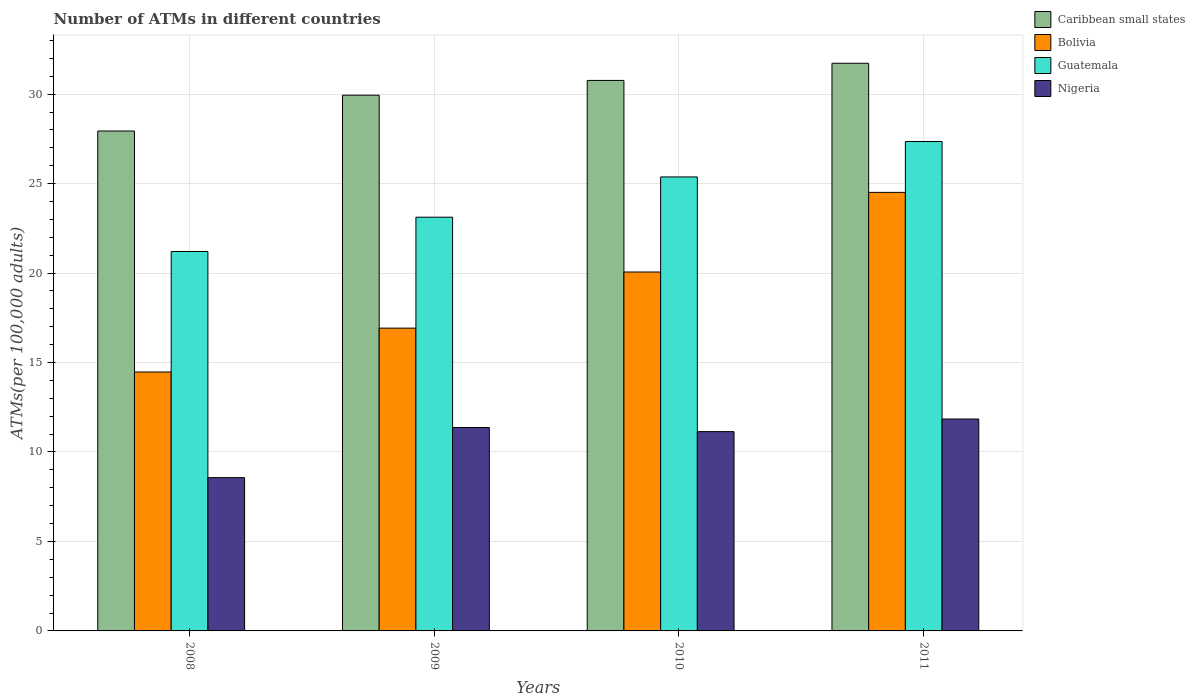Are the number of bars per tick equal to the number of legend labels?
Make the answer very short. Yes. Are the number of bars on each tick of the X-axis equal?
Offer a very short reply. Yes. How many bars are there on the 1st tick from the left?
Provide a short and direct response. 4. What is the label of the 3rd group of bars from the left?
Provide a succinct answer. 2010. What is the number of ATMs in Nigeria in 2008?
Offer a terse response. 8.57. Across all years, what is the maximum number of ATMs in Guatemala?
Offer a terse response. 27.35. Across all years, what is the minimum number of ATMs in Guatemala?
Provide a succinct answer. 21.21. In which year was the number of ATMs in Nigeria maximum?
Your answer should be compact. 2011. What is the total number of ATMs in Caribbean small states in the graph?
Provide a short and direct response. 120.38. What is the difference between the number of ATMs in Bolivia in 2009 and that in 2010?
Provide a short and direct response. -3.14. What is the difference between the number of ATMs in Guatemala in 2011 and the number of ATMs in Caribbean small states in 2008?
Your response must be concise. -0.59. What is the average number of ATMs in Guatemala per year?
Your answer should be very brief. 24.26. In the year 2011, what is the difference between the number of ATMs in Bolivia and number of ATMs in Caribbean small states?
Keep it short and to the point. -7.22. In how many years, is the number of ATMs in Caribbean small states greater than 30?
Give a very brief answer. 2. What is the ratio of the number of ATMs in Bolivia in 2008 to that in 2009?
Your answer should be very brief. 0.86. Is the difference between the number of ATMs in Bolivia in 2010 and 2011 greater than the difference between the number of ATMs in Caribbean small states in 2010 and 2011?
Offer a terse response. No. What is the difference between the highest and the second highest number of ATMs in Nigeria?
Ensure brevity in your answer.  0.47. What is the difference between the highest and the lowest number of ATMs in Bolivia?
Offer a terse response. 10.04. Is the sum of the number of ATMs in Nigeria in 2008 and 2009 greater than the maximum number of ATMs in Caribbean small states across all years?
Make the answer very short. No. What does the 1st bar from the left in 2009 represents?
Offer a very short reply. Caribbean small states. What does the 4th bar from the right in 2008 represents?
Give a very brief answer. Caribbean small states. Is it the case that in every year, the sum of the number of ATMs in Bolivia and number of ATMs in Nigeria is greater than the number of ATMs in Caribbean small states?
Offer a very short reply. No. How many bars are there?
Your answer should be very brief. 16. What is the difference between two consecutive major ticks on the Y-axis?
Offer a terse response. 5. Are the values on the major ticks of Y-axis written in scientific E-notation?
Your response must be concise. No. Does the graph contain any zero values?
Your response must be concise. No. Does the graph contain grids?
Your answer should be compact. Yes. What is the title of the graph?
Keep it short and to the point. Number of ATMs in different countries. Does "Gabon" appear as one of the legend labels in the graph?
Keep it short and to the point. No. What is the label or title of the Y-axis?
Your response must be concise. ATMs(per 100,0 adults). What is the ATMs(per 100,000 adults) of Caribbean small states in 2008?
Give a very brief answer. 27.94. What is the ATMs(per 100,000 adults) of Bolivia in 2008?
Keep it short and to the point. 14.47. What is the ATMs(per 100,000 adults) of Guatemala in 2008?
Your answer should be compact. 21.21. What is the ATMs(per 100,000 adults) in Nigeria in 2008?
Your response must be concise. 8.57. What is the ATMs(per 100,000 adults) of Caribbean small states in 2009?
Offer a terse response. 29.94. What is the ATMs(per 100,000 adults) of Bolivia in 2009?
Give a very brief answer. 16.92. What is the ATMs(per 100,000 adults) in Guatemala in 2009?
Provide a short and direct response. 23.12. What is the ATMs(per 100,000 adults) of Nigeria in 2009?
Keep it short and to the point. 11.37. What is the ATMs(per 100,000 adults) in Caribbean small states in 2010?
Your answer should be compact. 30.77. What is the ATMs(per 100,000 adults) in Bolivia in 2010?
Make the answer very short. 20.06. What is the ATMs(per 100,000 adults) of Guatemala in 2010?
Your answer should be compact. 25.37. What is the ATMs(per 100,000 adults) of Nigeria in 2010?
Make the answer very short. 11.14. What is the ATMs(per 100,000 adults) in Caribbean small states in 2011?
Offer a terse response. 31.73. What is the ATMs(per 100,000 adults) in Bolivia in 2011?
Keep it short and to the point. 24.51. What is the ATMs(per 100,000 adults) in Guatemala in 2011?
Your answer should be very brief. 27.35. What is the ATMs(per 100,000 adults) of Nigeria in 2011?
Offer a terse response. 11.84. Across all years, what is the maximum ATMs(per 100,000 adults) of Caribbean small states?
Give a very brief answer. 31.73. Across all years, what is the maximum ATMs(per 100,000 adults) of Bolivia?
Your answer should be very brief. 24.51. Across all years, what is the maximum ATMs(per 100,000 adults) of Guatemala?
Give a very brief answer. 27.35. Across all years, what is the maximum ATMs(per 100,000 adults) in Nigeria?
Provide a short and direct response. 11.84. Across all years, what is the minimum ATMs(per 100,000 adults) of Caribbean small states?
Provide a succinct answer. 27.94. Across all years, what is the minimum ATMs(per 100,000 adults) in Bolivia?
Make the answer very short. 14.47. Across all years, what is the minimum ATMs(per 100,000 adults) of Guatemala?
Your answer should be compact. 21.21. Across all years, what is the minimum ATMs(per 100,000 adults) of Nigeria?
Provide a short and direct response. 8.57. What is the total ATMs(per 100,000 adults) of Caribbean small states in the graph?
Offer a terse response. 120.38. What is the total ATMs(per 100,000 adults) of Bolivia in the graph?
Keep it short and to the point. 75.96. What is the total ATMs(per 100,000 adults) in Guatemala in the graph?
Offer a terse response. 97.06. What is the total ATMs(per 100,000 adults) of Nigeria in the graph?
Ensure brevity in your answer.  42.92. What is the difference between the ATMs(per 100,000 adults) in Caribbean small states in 2008 and that in 2009?
Give a very brief answer. -2. What is the difference between the ATMs(per 100,000 adults) of Bolivia in 2008 and that in 2009?
Your response must be concise. -2.45. What is the difference between the ATMs(per 100,000 adults) in Guatemala in 2008 and that in 2009?
Offer a terse response. -1.92. What is the difference between the ATMs(per 100,000 adults) of Nigeria in 2008 and that in 2009?
Provide a succinct answer. -2.8. What is the difference between the ATMs(per 100,000 adults) in Caribbean small states in 2008 and that in 2010?
Provide a short and direct response. -2.83. What is the difference between the ATMs(per 100,000 adults) in Bolivia in 2008 and that in 2010?
Offer a very short reply. -5.59. What is the difference between the ATMs(per 100,000 adults) in Guatemala in 2008 and that in 2010?
Make the answer very short. -4.17. What is the difference between the ATMs(per 100,000 adults) of Nigeria in 2008 and that in 2010?
Your answer should be very brief. -2.57. What is the difference between the ATMs(per 100,000 adults) of Caribbean small states in 2008 and that in 2011?
Ensure brevity in your answer.  -3.79. What is the difference between the ATMs(per 100,000 adults) of Bolivia in 2008 and that in 2011?
Ensure brevity in your answer.  -10.04. What is the difference between the ATMs(per 100,000 adults) of Guatemala in 2008 and that in 2011?
Your answer should be compact. -6.15. What is the difference between the ATMs(per 100,000 adults) in Nigeria in 2008 and that in 2011?
Offer a terse response. -3.28. What is the difference between the ATMs(per 100,000 adults) of Caribbean small states in 2009 and that in 2010?
Make the answer very short. -0.82. What is the difference between the ATMs(per 100,000 adults) of Bolivia in 2009 and that in 2010?
Provide a succinct answer. -3.14. What is the difference between the ATMs(per 100,000 adults) in Guatemala in 2009 and that in 2010?
Offer a very short reply. -2.25. What is the difference between the ATMs(per 100,000 adults) of Nigeria in 2009 and that in 2010?
Offer a terse response. 0.23. What is the difference between the ATMs(per 100,000 adults) in Caribbean small states in 2009 and that in 2011?
Offer a terse response. -1.78. What is the difference between the ATMs(per 100,000 adults) of Bolivia in 2009 and that in 2011?
Offer a terse response. -7.59. What is the difference between the ATMs(per 100,000 adults) in Guatemala in 2009 and that in 2011?
Your answer should be very brief. -4.23. What is the difference between the ATMs(per 100,000 adults) of Nigeria in 2009 and that in 2011?
Your response must be concise. -0.47. What is the difference between the ATMs(per 100,000 adults) in Caribbean small states in 2010 and that in 2011?
Provide a short and direct response. -0.96. What is the difference between the ATMs(per 100,000 adults) in Bolivia in 2010 and that in 2011?
Provide a short and direct response. -4.45. What is the difference between the ATMs(per 100,000 adults) in Guatemala in 2010 and that in 2011?
Your response must be concise. -1.98. What is the difference between the ATMs(per 100,000 adults) in Nigeria in 2010 and that in 2011?
Your response must be concise. -0.7. What is the difference between the ATMs(per 100,000 adults) in Caribbean small states in 2008 and the ATMs(per 100,000 adults) in Bolivia in 2009?
Offer a terse response. 11.02. What is the difference between the ATMs(per 100,000 adults) of Caribbean small states in 2008 and the ATMs(per 100,000 adults) of Guatemala in 2009?
Your response must be concise. 4.82. What is the difference between the ATMs(per 100,000 adults) of Caribbean small states in 2008 and the ATMs(per 100,000 adults) of Nigeria in 2009?
Offer a terse response. 16.57. What is the difference between the ATMs(per 100,000 adults) of Bolivia in 2008 and the ATMs(per 100,000 adults) of Guatemala in 2009?
Offer a terse response. -8.65. What is the difference between the ATMs(per 100,000 adults) of Bolivia in 2008 and the ATMs(per 100,000 adults) of Nigeria in 2009?
Make the answer very short. 3.1. What is the difference between the ATMs(per 100,000 adults) in Guatemala in 2008 and the ATMs(per 100,000 adults) in Nigeria in 2009?
Keep it short and to the point. 9.84. What is the difference between the ATMs(per 100,000 adults) in Caribbean small states in 2008 and the ATMs(per 100,000 adults) in Bolivia in 2010?
Your response must be concise. 7.88. What is the difference between the ATMs(per 100,000 adults) in Caribbean small states in 2008 and the ATMs(per 100,000 adults) in Guatemala in 2010?
Your answer should be compact. 2.57. What is the difference between the ATMs(per 100,000 adults) in Caribbean small states in 2008 and the ATMs(per 100,000 adults) in Nigeria in 2010?
Provide a succinct answer. 16.8. What is the difference between the ATMs(per 100,000 adults) in Bolivia in 2008 and the ATMs(per 100,000 adults) in Guatemala in 2010?
Keep it short and to the point. -10.9. What is the difference between the ATMs(per 100,000 adults) in Bolivia in 2008 and the ATMs(per 100,000 adults) in Nigeria in 2010?
Give a very brief answer. 3.33. What is the difference between the ATMs(per 100,000 adults) in Guatemala in 2008 and the ATMs(per 100,000 adults) in Nigeria in 2010?
Make the answer very short. 10.07. What is the difference between the ATMs(per 100,000 adults) in Caribbean small states in 2008 and the ATMs(per 100,000 adults) in Bolivia in 2011?
Your response must be concise. 3.43. What is the difference between the ATMs(per 100,000 adults) in Caribbean small states in 2008 and the ATMs(per 100,000 adults) in Guatemala in 2011?
Give a very brief answer. 0.59. What is the difference between the ATMs(per 100,000 adults) in Caribbean small states in 2008 and the ATMs(per 100,000 adults) in Nigeria in 2011?
Provide a short and direct response. 16.1. What is the difference between the ATMs(per 100,000 adults) in Bolivia in 2008 and the ATMs(per 100,000 adults) in Guatemala in 2011?
Your response must be concise. -12.88. What is the difference between the ATMs(per 100,000 adults) of Bolivia in 2008 and the ATMs(per 100,000 adults) of Nigeria in 2011?
Make the answer very short. 2.63. What is the difference between the ATMs(per 100,000 adults) of Guatemala in 2008 and the ATMs(per 100,000 adults) of Nigeria in 2011?
Provide a succinct answer. 9.36. What is the difference between the ATMs(per 100,000 adults) of Caribbean small states in 2009 and the ATMs(per 100,000 adults) of Bolivia in 2010?
Keep it short and to the point. 9.88. What is the difference between the ATMs(per 100,000 adults) in Caribbean small states in 2009 and the ATMs(per 100,000 adults) in Guatemala in 2010?
Your response must be concise. 4.57. What is the difference between the ATMs(per 100,000 adults) of Caribbean small states in 2009 and the ATMs(per 100,000 adults) of Nigeria in 2010?
Give a very brief answer. 18.8. What is the difference between the ATMs(per 100,000 adults) of Bolivia in 2009 and the ATMs(per 100,000 adults) of Guatemala in 2010?
Offer a terse response. -8.45. What is the difference between the ATMs(per 100,000 adults) of Bolivia in 2009 and the ATMs(per 100,000 adults) of Nigeria in 2010?
Your response must be concise. 5.78. What is the difference between the ATMs(per 100,000 adults) in Guatemala in 2009 and the ATMs(per 100,000 adults) in Nigeria in 2010?
Ensure brevity in your answer.  11.98. What is the difference between the ATMs(per 100,000 adults) in Caribbean small states in 2009 and the ATMs(per 100,000 adults) in Bolivia in 2011?
Give a very brief answer. 5.43. What is the difference between the ATMs(per 100,000 adults) of Caribbean small states in 2009 and the ATMs(per 100,000 adults) of Guatemala in 2011?
Provide a succinct answer. 2.59. What is the difference between the ATMs(per 100,000 adults) of Caribbean small states in 2009 and the ATMs(per 100,000 adults) of Nigeria in 2011?
Your answer should be compact. 18.1. What is the difference between the ATMs(per 100,000 adults) in Bolivia in 2009 and the ATMs(per 100,000 adults) in Guatemala in 2011?
Keep it short and to the point. -10.43. What is the difference between the ATMs(per 100,000 adults) in Bolivia in 2009 and the ATMs(per 100,000 adults) in Nigeria in 2011?
Offer a very short reply. 5.08. What is the difference between the ATMs(per 100,000 adults) in Guatemala in 2009 and the ATMs(per 100,000 adults) in Nigeria in 2011?
Your answer should be compact. 11.28. What is the difference between the ATMs(per 100,000 adults) of Caribbean small states in 2010 and the ATMs(per 100,000 adults) of Bolivia in 2011?
Give a very brief answer. 6.26. What is the difference between the ATMs(per 100,000 adults) in Caribbean small states in 2010 and the ATMs(per 100,000 adults) in Guatemala in 2011?
Make the answer very short. 3.41. What is the difference between the ATMs(per 100,000 adults) of Caribbean small states in 2010 and the ATMs(per 100,000 adults) of Nigeria in 2011?
Offer a very short reply. 18.92. What is the difference between the ATMs(per 100,000 adults) in Bolivia in 2010 and the ATMs(per 100,000 adults) in Guatemala in 2011?
Your answer should be very brief. -7.29. What is the difference between the ATMs(per 100,000 adults) of Bolivia in 2010 and the ATMs(per 100,000 adults) of Nigeria in 2011?
Offer a terse response. 8.22. What is the difference between the ATMs(per 100,000 adults) of Guatemala in 2010 and the ATMs(per 100,000 adults) of Nigeria in 2011?
Provide a short and direct response. 13.53. What is the average ATMs(per 100,000 adults) in Caribbean small states per year?
Give a very brief answer. 30.09. What is the average ATMs(per 100,000 adults) of Bolivia per year?
Offer a very short reply. 18.99. What is the average ATMs(per 100,000 adults) of Guatemala per year?
Keep it short and to the point. 24.26. What is the average ATMs(per 100,000 adults) in Nigeria per year?
Provide a succinct answer. 10.73. In the year 2008, what is the difference between the ATMs(per 100,000 adults) in Caribbean small states and ATMs(per 100,000 adults) in Bolivia?
Give a very brief answer. 13.47. In the year 2008, what is the difference between the ATMs(per 100,000 adults) of Caribbean small states and ATMs(per 100,000 adults) of Guatemala?
Your answer should be very brief. 6.73. In the year 2008, what is the difference between the ATMs(per 100,000 adults) of Caribbean small states and ATMs(per 100,000 adults) of Nigeria?
Keep it short and to the point. 19.37. In the year 2008, what is the difference between the ATMs(per 100,000 adults) of Bolivia and ATMs(per 100,000 adults) of Guatemala?
Your response must be concise. -6.74. In the year 2008, what is the difference between the ATMs(per 100,000 adults) of Bolivia and ATMs(per 100,000 adults) of Nigeria?
Your answer should be compact. 5.9. In the year 2008, what is the difference between the ATMs(per 100,000 adults) of Guatemala and ATMs(per 100,000 adults) of Nigeria?
Make the answer very short. 12.64. In the year 2009, what is the difference between the ATMs(per 100,000 adults) in Caribbean small states and ATMs(per 100,000 adults) in Bolivia?
Your answer should be very brief. 13.02. In the year 2009, what is the difference between the ATMs(per 100,000 adults) of Caribbean small states and ATMs(per 100,000 adults) of Guatemala?
Provide a succinct answer. 6.82. In the year 2009, what is the difference between the ATMs(per 100,000 adults) of Caribbean small states and ATMs(per 100,000 adults) of Nigeria?
Offer a terse response. 18.57. In the year 2009, what is the difference between the ATMs(per 100,000 adults) in Bolivia and ATMs(per 100,000 adults) in Guatemala?
Ensure brevity in your answer.  -6.2. In the year 2009, what is the difference between the ATMs(per 100,000 adults) in Bolivia and ATMs(per 100,000 adults) in Nigeria?
Provide a succinct answer. 5.55. In the year 2009, what is the difference between the ATMs(per 100,000 adults) of Guatemala and ATMs(per 100,000 adults) of Nigeria?
Your answer should be very brief. 11.75. In the year 2010, what is the difference between the ATMs(per 100,000 adults) in Caribbean small states and ATMs(per 100,000 adults) in Bolivia?
Your answer should be very brief. 10.71. In the year 2010, what is the difference between the ATMs(per 100,000 adults) of Caribbean small states and ATMs(per 100,000 adults) of Guatemala?
Your answer should be compact. 5.39. In the year 2010, what is the difference between the ATMs(per 100,000 adults) in Caribbean small states and ATMs(per 100,000 adults) in Nigeria?
Offer a terse response. 19.63. In the year 2010, what is the difference between the ATMs(per 100,000 adults) of Bolivia and ATMs(per 100,000 adults) of Guatemala?
Give a very brief answer. -5.31. In the year 2010, what is the difference between the ATMs(per 100,000 adults) in Bolivia and ATMs(per 100,000 adults) in Nigeria?
Offer a very short reply. 8.92. In the year 2010, what is the difference between the ATMs(per 100,000 adults) in Guatemala and ATMs(per 100,000 adults) in Nigeria?
Provide a short and direct response. 14.23. In the year 2011, what is the difference between the ATMs(per 100,000 adults) in Caribbean small states and ATMs(per 100,000 adults) in Bolivia?
Your answer should be compact. 7.22. In the year 2011, what is the difference between the ATMs(per 100,000 adults) in Caribbean small states and ATMs(per 100,000 adults) in Guatemala?
Keep it short and to the point. 4.37. In the year 2011, what is the difference between the ATMs(per 100,000 adults) of Caribbean small states and ATMs(per 100,000 adults) of Nigeria?
Keep it short and to the point. 19.88. In the year 2011, what is the difference between the ATMs(per 100,000 adults) in Bolivia and ATMs(per 100,000 adults) in Guatemala?
Provide a succinct answer. -2.84. In the year 2011, what is the difference between the ATMs(per 100,000 adults) of Bolivia and ATMs(per 100,000 adults) of Nigeria?
Your response must be concise. 12.67. In the year 2011, what is the difference between the ATMs(per 100,000 adults) in Guatemala and ATMs(per 100,000 adults) in Nigeria?
Your answer should be very brief. 15.51. What is the ratio of the ATMs(per 100,000 adults) in Caribbean small states in 2008 to that in 2009?
Your answer should be compact. 0.93. What is the ratio of the ATMs(per 100,000 adults) of Bolivia in 2008 to that in 2009?
Make the answer very short. 0.86. What is the ratio of the ATMs(per 100,000 adults) in Guatemala in 2008 to that in 2009?
Provide a succinct answer. 0.92. What is the ratio of the ATMs(per 100,000 adults) of Nigeria in 2008 to that in 2009?
Make the answer very short. 0.75. What is the ratio of the ATMs(per 100,000 adults) in Caribbean small states in 2008 to that in 2010?
Keep it short and to the point. 0.91. What is the ratio of the ATMs(per 100,000 adults) in Bolivia in 2008 to that in 2010?
Offer a very short reply. 0.72. What is the ratio of the ATMs(per 100,000 adults) of Guatemala in 2008 to that in 2010?
Your response must be concise. 0.84. What is the ratio of the ATMs(per 100,000 adults) in Nigeria in 2008 to that in 2010?
Offer a very short reply. 0.77. What is the ratio of the ATMs(per 100,000 adults) of Caribbean small states in 2008 to that in 2011?
Ensure brevity in your answer.  0.88. What is the ratio of the ATMs(per 100,000 adults) of Bolivia in 2008 to that in 2011?
Provide a short and direct response. 0.59. What is the ratio of the ATMs(per 100,000 adults) of Guatemala in 2008 to that in 2011?
Your response must be concise. 0.78. What is the ratio of the ATMs(per 100,000 adults) in Nigeria in 2008 to that in 2011?
Provide a short and direct response. 0.72. What is the ratio of the ATMs(per 100,000 adults) of Caribbean small states in 2009 to that in 2010?
Your response must be concise. 0.97. What is the ratio of the ATMs(per 100,000 adults) of Bolivia in 2009 to that in 2010?
Offer a very short reply. 0.84. What is the ratio of the ATMs(per 100,000 adults) in Guatemala in 2009 to that in 2010?
Make the answer very short. 0.91. What is the ratio of the ATMs(per 100,000 adults) in Nigeria in 2009 to that in 2010?
Provide a short and direct response. 1.02. What is the ratio of the ATMs(per 100,000 adults) of Caribbean small states in 2009 to that in 2011?
Ensure brevity in your answer.  0.94. What is the ratio of the ATMs(per 100,000 adults) of Bolivia in 2009 to that in 2011?
Offer a terse response. 0.69. What is the ratio of the ATMs(per 100,000 adults) in Guatemala in 2009 to that in 2011?
Ensure brevity in your answer.  0.85. What is the ratio of the ATMs(per 100,000 adults) in Nigeria in 2009 to that in 2011?
Provide a succinct answer. 0.96. What is the ratio of the ATMs(per 100,000 adults) in Caribbean small states in 2010 to that in 2011?
Your answer should be very brief. 0.97. What is the ratio of the ATMs(per 100,000 adults) of Bolivia in 2010 to that in 2011?
Offer a terse response. 0.82. What is the ratio of the ATMs(per 100,000 adults) of Guatemala in 2010 to that in 2011?
Your response must be concise. 0.93. What is the ratio of the ATMs(per 100,000 adults) in Nigeria in 2010 to that in 2011?
Ensure brevity in your answer.  0.94. What is the difference between the highest and the second highest ATMs(per 100,000 adults) of Caribbean small states?
Your answer should be very brief. 0.96. What is the difference between the highest and the second highest ATMs(per 100,000 adults) of Bolivia?
Offer a terse response. 4.45. What is the difference between the highest and the second highest ATMs(per 100,000 adults) in Guatemala?
Offer a very short reply. 1.98. What is the difference between the highest and the second highest ATMs(per 100,000 adults) in Nigeria?
Provide a succinct answer. 0.47. What is the difference between the highest and the lowest ATMs(per 100,000 adults) of Caribbean small states?
Make the answer very short. 3.79. What is the difference between the highest and the lowest ATMs(per 100,000 adults) in Bolivia?
Offer a very short reply. 10.04. What is the difference between the highest and the lowest ATMs(per 100,000 adults) of Guatemala?
Make the answer very short. 6.15. What is the difference between the highest and the lowest ATMs(per 100,000 adults) of Nigeria?
Make the answer very short. 3.28. 